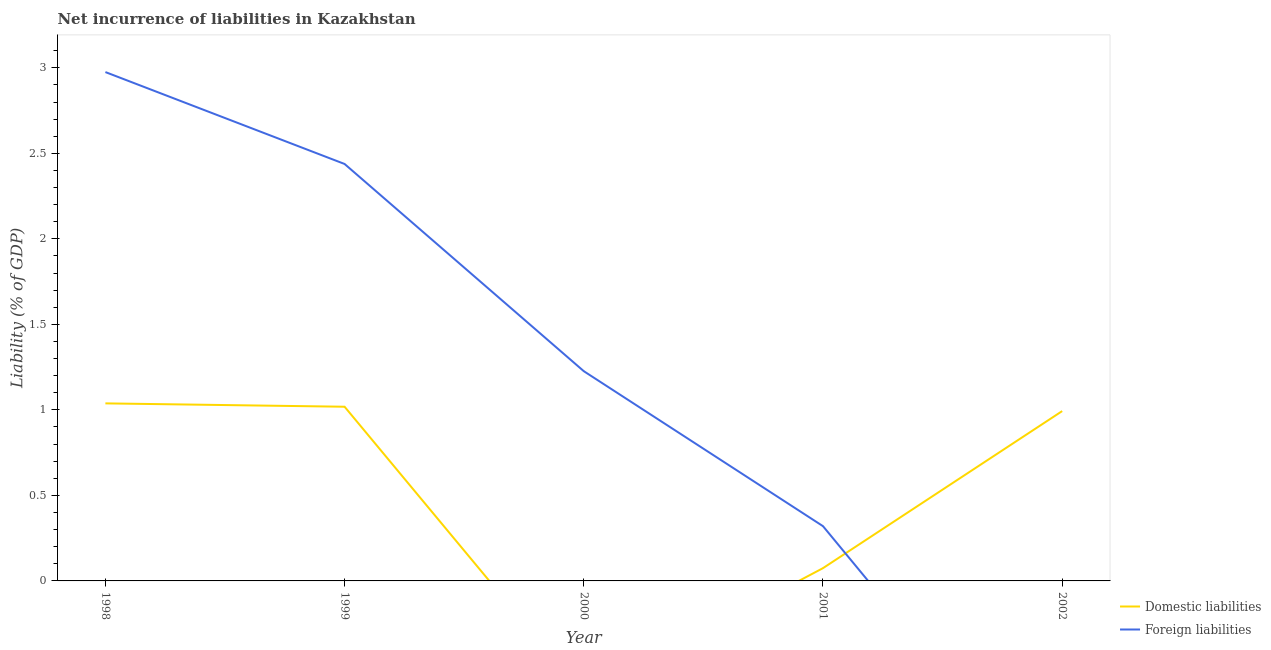How many different coloured lines are there?
Ensure brevity in your answer.  2. What is the incurrence of foreign liabilities in 2000?
Keep it short and to the point. 1.23. Across all years, what is the maximum incurrence of foreign liabilities?
Provide a succinct answer. 2.98. In which year was the incurrence of foreign liabilities maximum?
Your answer should be very brief. 1998. What is the total incurrence of foreign liabilities in the graph?
Make the answer very short. 6.96. What is the difference between the incurrence of foreign liabilities in 1998 and that in 2000?
Ensure brevity in your answer.  1.75. What is the difference between the incurrence of foreign liabilities in 2001 and the incurrence of domestic liabilities in 2000?
Provide a short and direct response. 0.32. What is the average incurrence of domestic liabilities per year?
Provide a succinct answer. 0.62. In the year 1999, what is the difference between the incurrence of domestic liabilities and incurrence of foreign liabilities?
Keep it short and to the point. -1.42. In how many years, is the incurrence of domestic liabilities greater than 0.30000000000000004 %?
Ensure brevity in your answer.  3. What is the ratio of the incurrence of domestic liabilities in 1998 to that in 1999?
Keep it short and to the point. 1.02. Is the incurrence of domestic liabilities in 1998 less than that in 2002?
Give a very brief answer. No. Is the difference between the incurrence of foreign liabilities in 1999 and 2001 greater than the difference between the incurrence of domestic liabilities in 1999 and 2001?
Ensure brevity in your answer.  Yes. What is the difference between the highest and the second highest incurrence of domestic liabilities?
Provide a short and direct response. 0.02. What is the difference between the highest and the lowest incurrence of domestic liabilities?
Offer a very short reply. 1.04. In how many years, is the incurrence of foreign liabilities greater than the average incurrence of foreign liabilities taken over all years?
Offer a very short reply. 2. Does the incurrence of domestic liabilities monotonically increase over the years?
Keep it short and to the point. No. Is the incurrence of foreign liabilities strictly less than the incurrence of domestic liabilities over the years?
Your response must be concise. No. How many years are there in the graph?
Make the answer very short. 5. Does the graph contain grids?
Offer a terse response. No. Where does the legend appear in the graph?
Offer a terse response. Bottom right. How are the legend labels stacked?
Your answer should be compact. Vertical. What is the title of the graph?
Give a very brief answer. Net incurrence of liabilities in Kazakhstan. Does "Mobile cellular" appear as one of the legend labels in the graph?
Ensure brevity in your answer.  No. What is the label or title of the X-axis?
Your response must be concise. Year. What is the label or title of the Y-axis?
Offer a terse response. Liability (% of GDP). What is the Liability (% of GDP) of Domestic liabilities in 1998?
Ensure brevity in your answer.  1.04. What is the Liability (% of GDP) of Foreign liabilities in 1998?
Offer a terse response. 2.98. What is the Liability (% of GDP) in Domestic liabilities in 1999?
Offer a very short reply. 1.02. What is the Liability (% of GDP) of Foreign liabilities in 1999?
Offer a terse response. 2.44. What is the Liability (% of GDP) in Foreign liabilities in 2000?
Offer a very short reply. 1.23. What is the Liability (% of GDP) in Domestic liabilities in 2001?
Your answer should be compact. 0.07. What is the Liability (% of GDP) in Foreign liabilities in 2001?
Provide a short and direct response. 0.32. What is the Liability (% of GDP) of Domestic liabilities in 2002?
Your response must be concise. 0.99. What is the Liability (% of GDP) of Foreign liabilities in 2002?
Keep it short and to the point. 0. Across all years, what is the maximum Liability (% of GDP) of Domestic liabilities?
Offer a very short reply. 1.04. Across all years, what is the maximum Liability (% of GDP) in Foreign liabilities?
Give a very brief answer. 2.98. What is the total Liability (% of GDP) in Domestic liabilities in the graph?
Give a very brief answer. 3.12. What is the total Liability (% of GDP) of Foreign liabilities in the graph?
Offer a very short reply. 6.96. What is the difference between the Liability (% of GDP) of Domestic liabilities in 1998 and that in 1999?
Offer a terse response. 0.02. What is the difference between the Liability (% of GDP) in Foreign liabilities in 1998 and that in 1999?
Keep it short and to the point. 0.54. What is the difference between the Liability (% of GDP) in Foreign liabilities in 1998 and that in 2000?
Make the answer very short. 1.75. What is the difference between the Liability (% of GDP) of Domestic liabilities in 1998 and that in 2001?
Give a very brief answer. 0.96. What is the difference between the Liability (% of GDP) of Foreign liabilities in 1998 and that in 2001?
Provide a succinct answer. 2.66. What is the difference between the Liability (% of GDP) of Domestic liabilities in 1998 and that in 2002?
Give a very brief answer. 0.05. What is the difference between the Liability (% of GDP) of Foreign liabilities in 1999 and that in 2000?
Provide a short and direct response. 1.21. What is the difference between the Liability (% of GDP) of Domestic liabilities in 1999 and that in 2001?
Offer a terse response. 0.94. What is the difference between the Liability (% of GDP) of Foreign liabilities in 1999 and that in 2001?
Provide a succinct answer. 2.12. What is the difference between the Liability (% of GDP) in Domestic liabilities in 1999 and that in 2002?
Make the answer very short. 0.03. What is the difference between the Liability (% of GDP) of Foreign liabilities in 2000 and that in 2001?
Your response must be concise. 0.91. What is the difference between the Liability (% of GDP) in Domestic liabilities in 2001 and that in 2002?
Give a very brief answer. -0.92. What is the difference between the Liability (% of GDP) of Domestic liabilities in 1998 and the Liability (% of GDP) of Foreign liabilities in 1999?
Provide a succinct answer. -1.4. What is the difference between the Liability (% of GDP) of Domestic liabilities in 1998 and the Liability (% of GDP) of Foreign liabilities in 2000?
Keep it short and to the point. -0.19. What is the difference between the Liability (% of GDP) in Domestic liabilities in 1998 and the Liability (% of GDP) in Foreign liabilities in 2001?
Make the answer very short. 0.72. What is the difference between the Liability (% of GDP) of Domestic liabilities in 1999 and the Liability (% of GDP) of Foreign liabilities in 2000?
Your answer should be compact. -0.21. What is the difference between the Liability (% of GDP) of Domestic liabilities in 1999 and the Liability (% of GDP) of Foreign liabilities in 2001?
Keep it short and to the point. 0.7. What is the average Liability (% of GDP) of Domestic liabilities per year?
Your response must be concise. 0.62. What is the average Liability (% of GDP) in Foreign liabilities per year?
Provide a succinct answer. 1.39. In the year 1998, what is the difference between the Liability (% of GDP) of Domestic liabilities and Liability (% of GDP) of Foreign liabilities?
Provide a short and direct response. -1.94. In the year 1999, what is the difference between the Liability (% of GDP) of Domestic liabilities and Liability (% of GDP) of Foreign liabilities?
Ensure brevity in your answer.  -1.42. In the year 2001, what is the difference between the Liability (% of GDP) of Domestic liabilities and Liability (% of GDP) of Foreign liabilities?
Give a very brief answer. -0.25. What is the ratio of the Liability (% of GDP) of Domestic liabilities in 1998 to that in 1999?
Your response must be concise. 1.02. What is the ratio of the Liability (% of GDP) in Foreign liabilities in 1998 to that in 1999?
Your response must be concise. 1.22. What is the ratio of the Liability (% of GDP) in Foreign liabilities in 1998 to that in 2000?
Your answer should be very brief. 2.43. What is the ratio of the Liability (% of GDP) of Foreign liabilities in 1998 to that in 2001?
Provide a succinct answer. 9.29. What is the ratio of the Liability (% of GDP) of Domestic liabilities in 1998 to that in 2002?
Your answer should be compact. 1.05. What is the ratio of the Liability (% of GDP) of Foreign liabilities in 1999 to that in 2000?
Offer a terse response. 1.99. What is the ratio of the Liability (% of GDP) of Domestic liabilities in 1999 to that in 2001?
Provide a succinct answer. 13.64. What is the ratio of the Liability (% of GDP) of Foreign liabilities in 1999 to that in 2001?
Your answer should be compact. 7.61. What is the ratio of the Liability (% of GDP) in Domestic liabilities in 1999 to that in 2002?
Keep it short and to the point. 1.03. What is the ratio of the Liability (% of GDP) in Foreign liabilities in 2000 to that in 2001?
Offer a very short reply. 3.83. What is the ratio of the Liability (% of GDP) in Domestic liabilities in 2001 to that in 2002?
Your response must be concise. 0.08. What is the difference between the highest and the second highest Liability (% of GDP) in Domestic liabilities?
Make the answer very short. 0.02. What is the difference between the highest and the second highest Liability (% of GDP) in Foreign liabilities?
Your answer should be very brief. 0.54. What is the difference between the highest and the lowest Liability (% of GDP) of Domestic liabilities?
Your response must be concise. 1.04. What is the difference between the highest and the lowest Liability (% of GDP) of Foreign liabilities?
Keep it short and to the point. 2.98. 